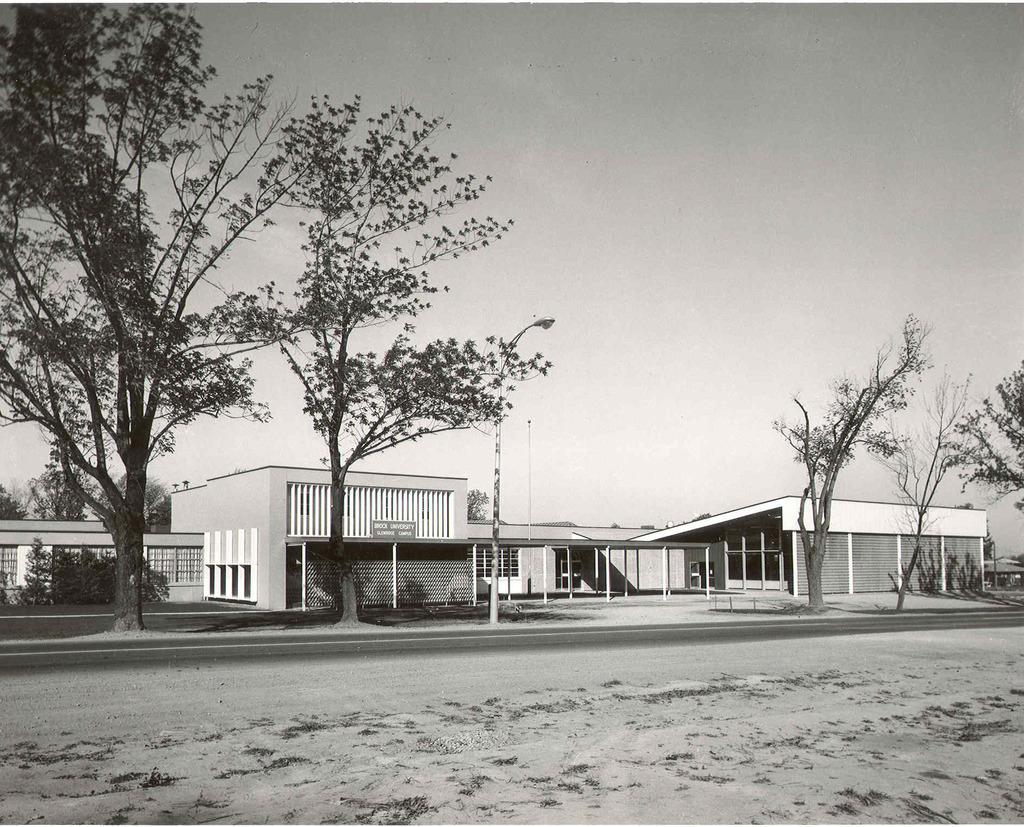What type of pathway is visible in the image? There is a road in the image. What is located in the center of the image? There is a pole in the center of the image. What type of vegetation can be seen in the image? There are trees in the image. What type of structures are present in the image? There are buildings in the image. What is visible at the top of the image? The sky is visible at the top of the image. What type of story is being told by the branch in the image? There is no branch present in the image, and therefore no story can be told by it. What type of horn can be seen on the pole in the image? There is no horn present on the pole in the image. 